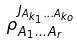Convert formula to latex. <formula><loc_0><loc_0><loc_500><loc_500>\rho _ { A _ { 1 } \dots A _ { r } } ^ { J _ { A _ { k _ { 1 } } \dots A _ { k _ { o } } } }</formula> 